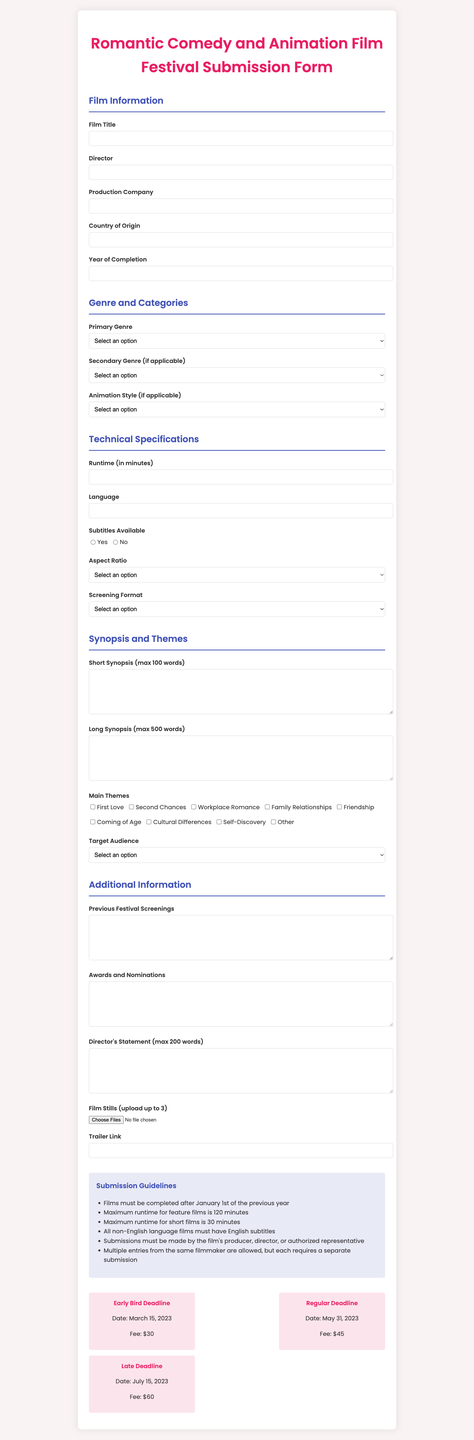what is the title of the film festival? The title of the film festival is stated at the top of the document.
Answer: Love & Laughter International Film Festival what is the maximum runtime for feature films? The document specifies the maximum runtime for feature films under the submission guidelines.
Answer: 120 minutes who is required to submit the film? Information about who can submit the film is provided in the submission guidelines.
Answer: Producer, director, or authorized representative what are the primary genres allowed for submission? The primary genres are listed in the Genre and Categories section of the document.
Answer: Romantic Comedy, Animation, Animated Romantic Comedy what is the deadline for early bird submissions? The early bird submission date is provided in the submission deadlines section.
Answer: March 15, 2023 what is the format for screening submissions? The document provides options for screening format in the technical specifications section.
Answer: DCP, Blu-ray, ProRes, H.264, Other which language is required for non-English films? The guidelines specify language requirements for non-English language films.
Answer: English what is the maximum word count for the long synopsis? The document specifies the limit for the long synopsis in the synopsis and themes section.
Answer: 500 words what should be included in the director's statement? The document indicates the content required for the director's statement.
Answer: Max 200 words 